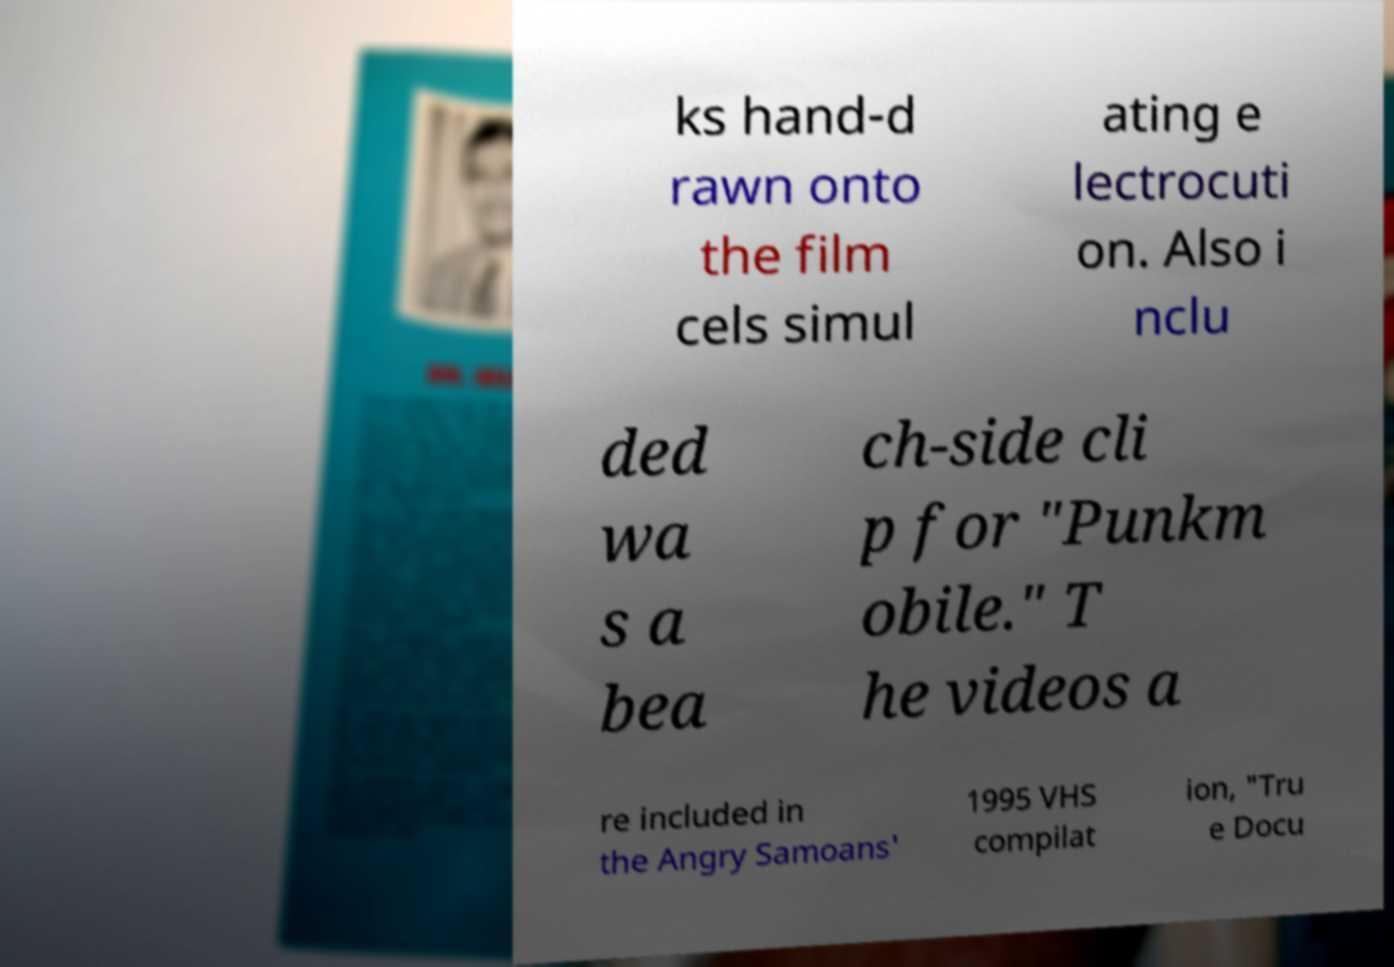There's text embedded in this image that I need extracted. Can you transcribe it verbatim? ks hand-d rawn onto the film cels simul ating e lectrocuti on. Also i nclu ded wa s a bea ch-side cli p for "Punkm obile." T he videos a re included in the Angry Samoans' 1995 VHS compilat ion, "Tru e Docu 